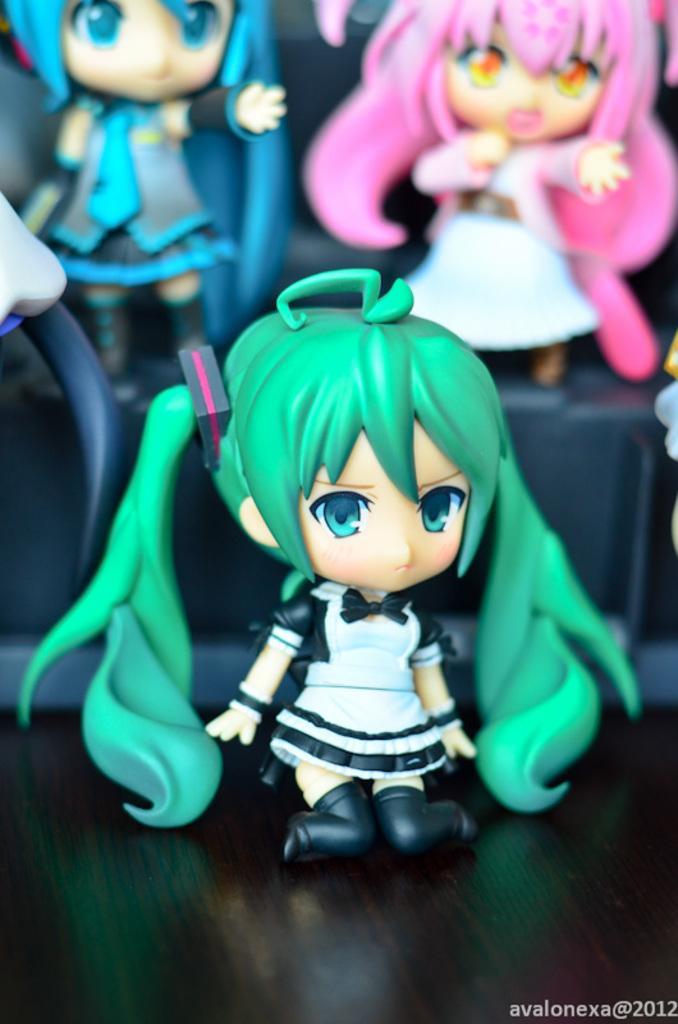Please provide a concise description of this image. In this image we can see toys. This is black surface. Bottom of the image there is a watermark. 